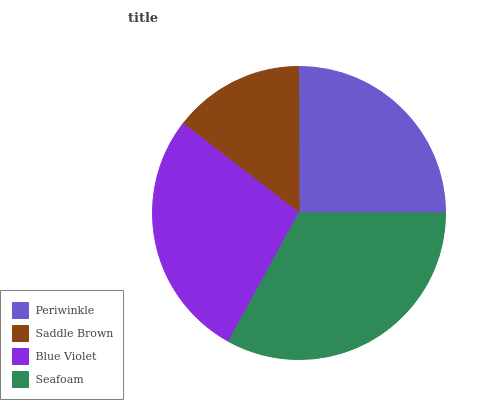Is Saddle Brown the minimum?
Answer yes or no. Yes. Is Seafoam the maximum?
Answer yes or no. Yes. Is Blue Violet the minimum?
Answer yes or no. No. Is Blue Violet the maximum?
Answer yes or no. No. Is Blue Violet greater than Saddle Brown?
Answer yes or no. Yes. Is Saddle Brown less than Blue Violet?
Answer yes or no. Yes. Is Saddle Brown greater than Blue Violet?
Answer yes or no. No. Is Blue Violet less than Saddle Brown?
Answer yes or no. No. Is Blue Violet the high median?
Answer yes or no. Yes. Is Periwinkle the low median?
Answer yes or no. Yes. Is Periwinkle the high median?
Answer yes or no. No. Is Seafoam the low median?
Answer yes or no. No. 